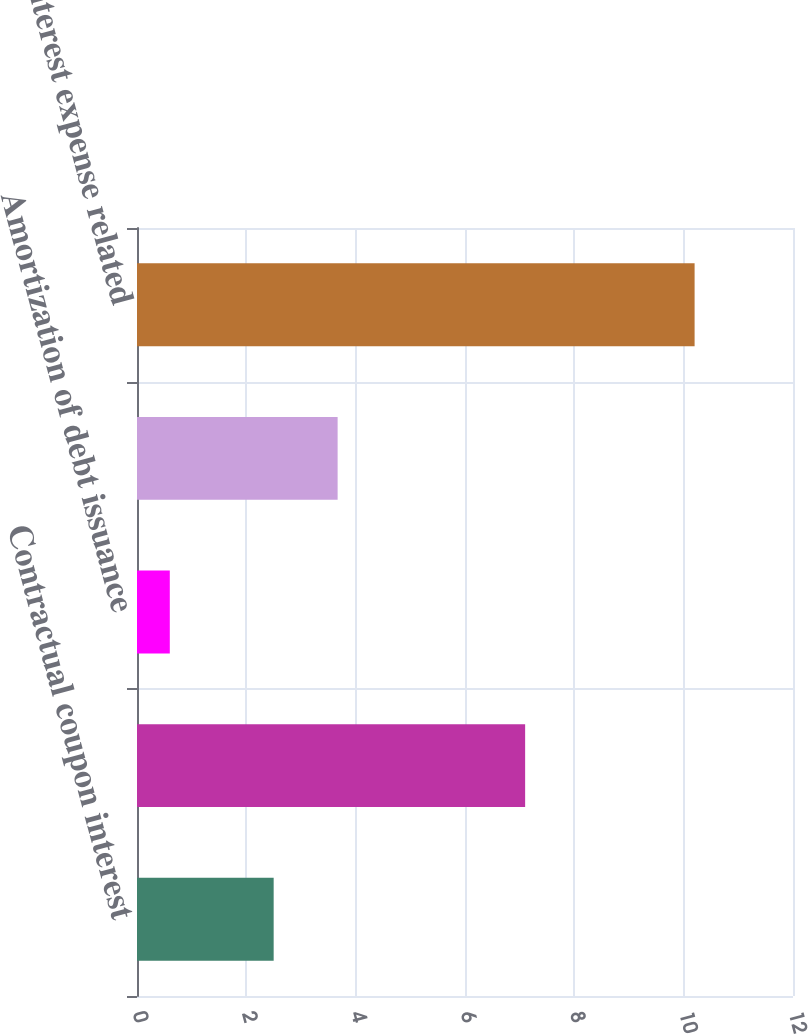Convert chart. <chart><loc_0><loc_0><loc_500><loc_500><bar_chart><fcel>Contractual coupon interest<fcel>Amortization of debt discount<fcel>Amortization of debt issuance<fcel>Less capitalized interest<fcel>Total interest expense related<nl><fcel>2.5<fcel>7.1<fcel>0.6<fcel>3.67<fcel>10.2<nl></chart> 